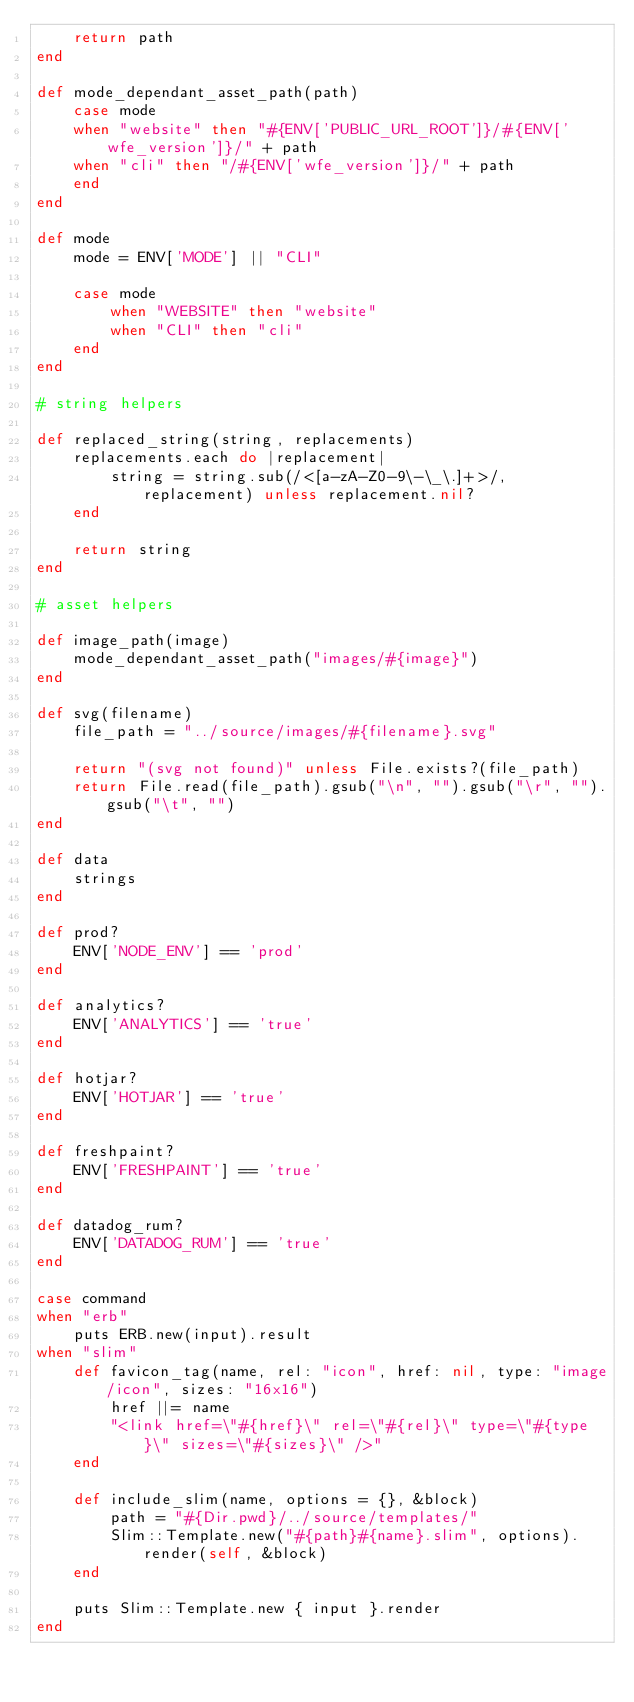Convert code to text. <code><loc_0><loc_0><loc_500><loc_500><_Ruby_>    return path
end

def mode_dependant_asset_path(path)
    case mode
    when "website" then "#{ENV['PUBLIC_URL_ROOT']}/#{ENV['wfe_version']}/" + path
    when "cli" then "/#{ENV['wfe_version']}/" + path
    end
end

def mode
    mode = ENV['MODE'] || "CLI"

    case mode
        when "WEBSITE" then "website"
        when "CLI" then "cli"
    end
end

# string helpers

def replaced_string(string, replacements)
    replacements.each do |replacement|
        string = string.sub(/<[a-zA-Z0-9\-\_\.]+>/, replacement) unless replacement.nil?
    end

    return string
end

# asset helpers

def image_path(image)
    mode_dependant_asset_path("images/#{image}")
end

def svg(filename)
    file_path = "../source/images/#{filename}.svg"

    return "(svg not found)" unless File.exists?(file_path)
    return File.read(file_path).gsub("\n", "").gsub("\r", "").gsub("\t", "")
end

def data
    strings
end

def prod?
    ENV['NODE_ENV'] == 'prod'
end

def analytics?
    ENV['ANALYTICS'] == 'true'
end

def hotjar?
    ENV['HOTJAR'] == 'true'
end

def freshpaint?
    ENV['FRESHPAINT'] == 'true'
end

def datadog_rum?
    ENV['DATADOG_RUM'] == 'true'
end

case command
when "erb"
    puts ERB.new(input).result
when "slim"
    def favicon_tag(name, rel: "icon", href: nil, type: "image/icon", sizes: "16x16")
        href ||= name
        "<link href=\"#{href}\" rel=\"#{rel}\" type=\"#{type}\" sizes=\"#{sizes}\" />"
    end

    def include_slim(name, options = {}, &block)
        path = "#{Dir.pwd}/../source/templates/"
        Slim::Template.new("#{path}#{name}.slim", options).render(self, &block)
    end

    puts Slim::Template.new { input }.render
end
</code> 